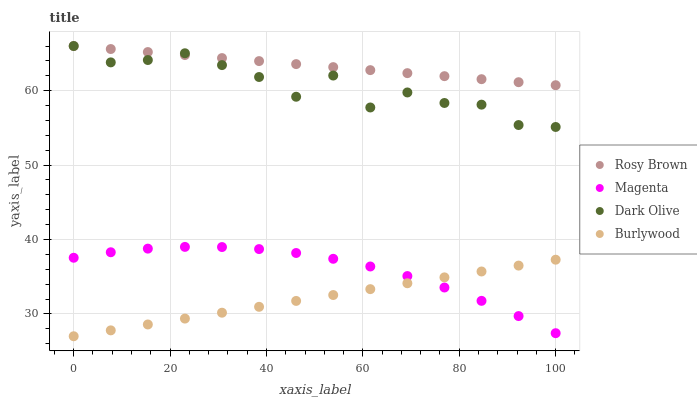Does Burlywood have the minimum area under the curve?
Answer yes or no. Yes. Does Rosy Brown have the maximum area under the curve?
Answer yes or no. Yes. Does Magenta have the minimum area under the curve?
Answer yes or no. No. Does Magenta have the maximum area under the curve?
Answer yes or no. No. Is Burlywood the smoothest?
Answer yes or no. Yes. Is Dark Olive the roughest?
Answer yes or no. Yes. Is Magenta the smoothest?
Answer yes or no. No. Is Magenta the roughest?
Answer yes or no. No. Does Burlywood have the lowest value?
Answer yes or no. Yes. Does Magenta have the lowest value?
Answer yes or no. No. Does Rosy Brown have the highest value?
Answer yes or no. Yes. Does Magenta have the highest value?
Answer yes or no. No. Is Magenta less than Dark Olive?
Answer yes or no. Yes. Is Rosy Brown greater than Burlywood?
Answer yes or no. Yes. Does Dark Olive intersect Rosy Brown?
Answer yes or no. Yes. Is Dark Olive less than Rosy Brown?
Answer yes or no. No. Is Dark Olive greater than Rosy Brown?
Answer yes or no. No. Does Magenta intersect Dark Olive?
Answer yes or no. No. 